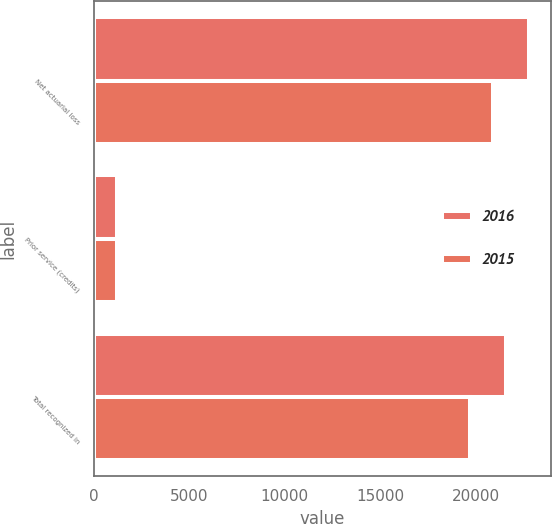<chart> <loc_0><loc_0><loc_500><loc_500><stacked_bar_chart><ecel><fcel>Net actuarial loss<fcel>Prior service (credits)<fcel>Total recognized in<nl><fcel>2016<fcel>22802<fcel>1243<fcel>21559<nl><fcel>2015<fcel>20871<fcel>1195<fcel>19676<nl></chart> 